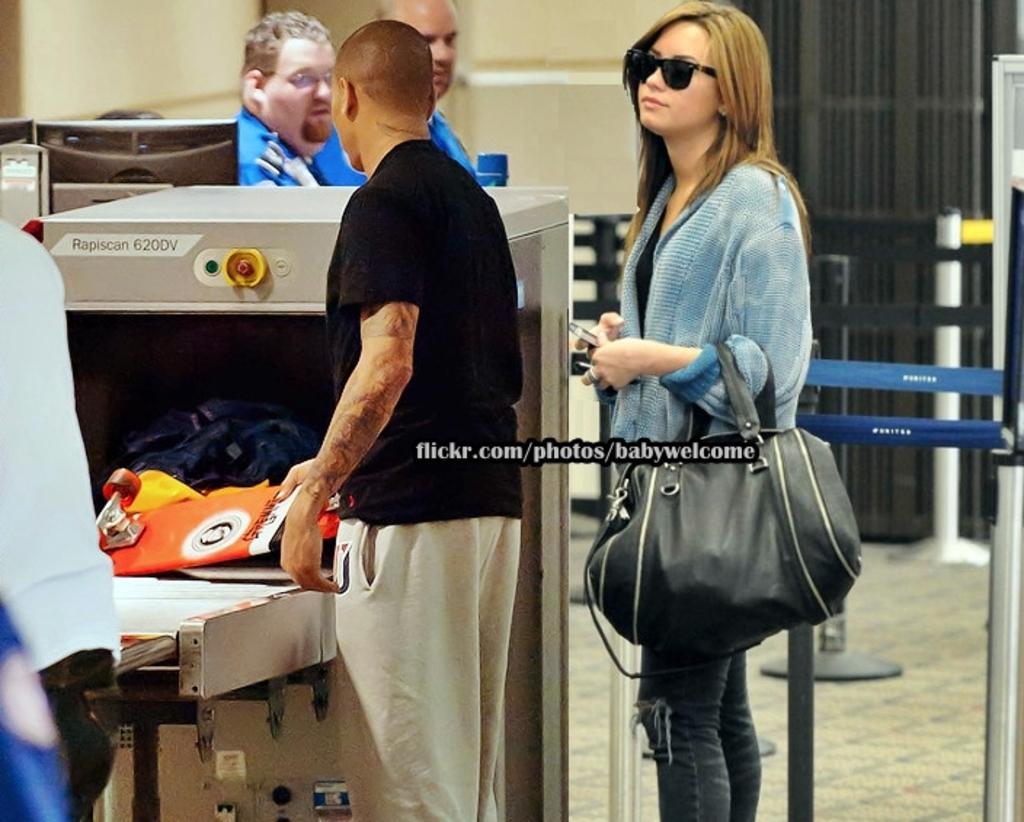How would you summarize this image in a sentence or two? In the image there are two people. Man and woman are standing, woman is wearing a blue color shirt and she is also holding a hand on her hand we can also see a man standing near a table. On table we can see some colors, in background there are two men's wall which is in cream color and a curtain in black color. 